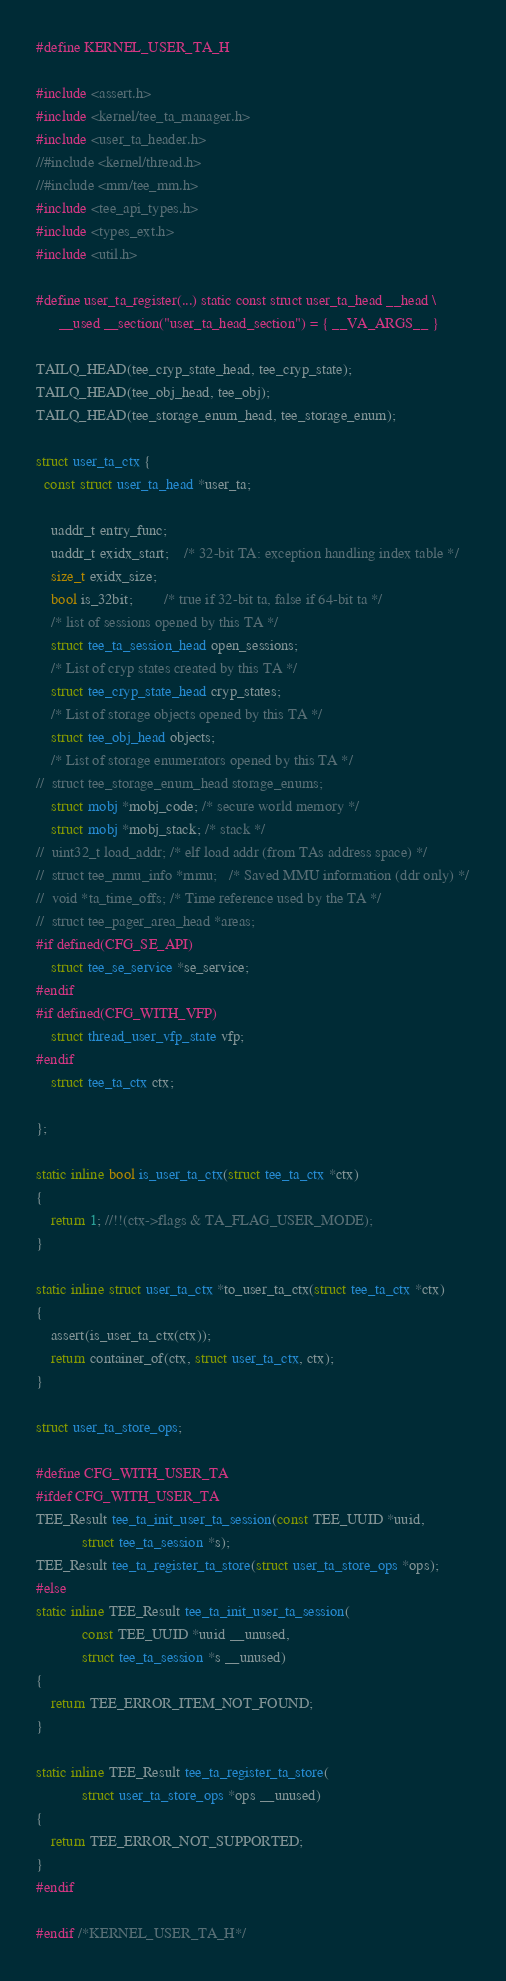<code> <loc_0><loc_0><loc_500><loc_500><_C_>#define KERNEL_USER_TA_H

#include <assert.h>
#include <kernel/tee_ta_manager.h>
#include <user_ta_header.h>
//#include <kernel/thread.h>
//#include <mm/tee_mm.h>
#include <tee_api_types.h>
#include <types_ext.h>
#include <util.h>

#define user_ta_register(...) static const struct user_ta_head __head \
      __used __section("user_ta_head_section") = { __VA_ARGS__ }

TAILQ_HEAD(tee_cryp_state_head, tee_cryp_state);
TAILQ_HEAD(tee_obj_head, tee_obj);
TAILQ_HEAD(tee_storage_enum_head, tee_storage_enum);

struct user_ta_ctx {
  const struct user_ta_head *user_ta;

	uaddr_t entry_func;
	uaddr_t exidx_start;	/* 32-bit TA: exception handling index table */
	size_t exidx_size;
	bool is_32bit;		/* true if 32-bit ta, false if 64-bit ta */
	/* list of sessions opened by this TA */
	struct tee_ta_session_head open_sessions;
	/* List of cryp states created by this TA */
	struct tee_cryp_state_head cryp_states;
	/* List of storage objects opened by this TA */
	struct tee_obj_head objects;
	/* List of storage enumerators opened by this TA */
//	struct tee_storage_enum_head storage_enums;
	struct mobj *mobj_code; /* secure world memory */
	struct mobj *mobj_stack; /* stack */
//	uint32_t load_addr;	/* elf load addr (from TAs address space) */
//	struct tee_mmu_info *mmu;	/* Saved MMU information (ddr only) */
//	void *ta_time_offs;	/* Time reference used by the TA */
//	struct tee_pager_area_head *areas;
#if defined(CFG_SE_API)
	struct tee_se_service *se_service;
#endif
#if defined(CFG_WITH_VFP)
	struct thread_user_vfp_state vfp;
#endif
	struct tee_ta_ctx ctx;

};

static inline bool is_user_ta_ctx(struct tee_ta_ctx *ctx)
{
	return 1; //!!(ctx->flags & TA_FLAG_USER_MODE);
}

static inline struct user_ta_ctx *to_user_ta_ctx(struct tee_ta_ctx *ctx)
{
	assert(is_user_ta_ctx(ctx));
	return container_of(ctx, struct user_ta_ctx, ctx);
}

struct user_ta_store_ops;

#define CFG_WITH_USER_TA
#ifdef CFG_WITH_USER_TA
TEE_Result tee_ta_init_user_ta_session(const TEE_UUID *uuid,
			struct tee_ta_session *s);
TEE_Result tee_ta_register_ta_store(struct user_ta_store_ops *ops);
#else
static inline TEE_Result tee_ta_init_user_ta_session(
			const TEE_UUID *uuid __unused,
			struct tee_ta_session *s __unused)
{
	return TEE_ERROR_ITEM_NOT_FOUND;
}

static inline TEE_Result tee_ta_register_ta_store(
			struct user_ta_store_ops *ops __unused)
{
	return TEE_ERROR_NOT_SUPPORTED;
}
#endif

#endif /*KERNEL_USER_TA_H*/
</code> 